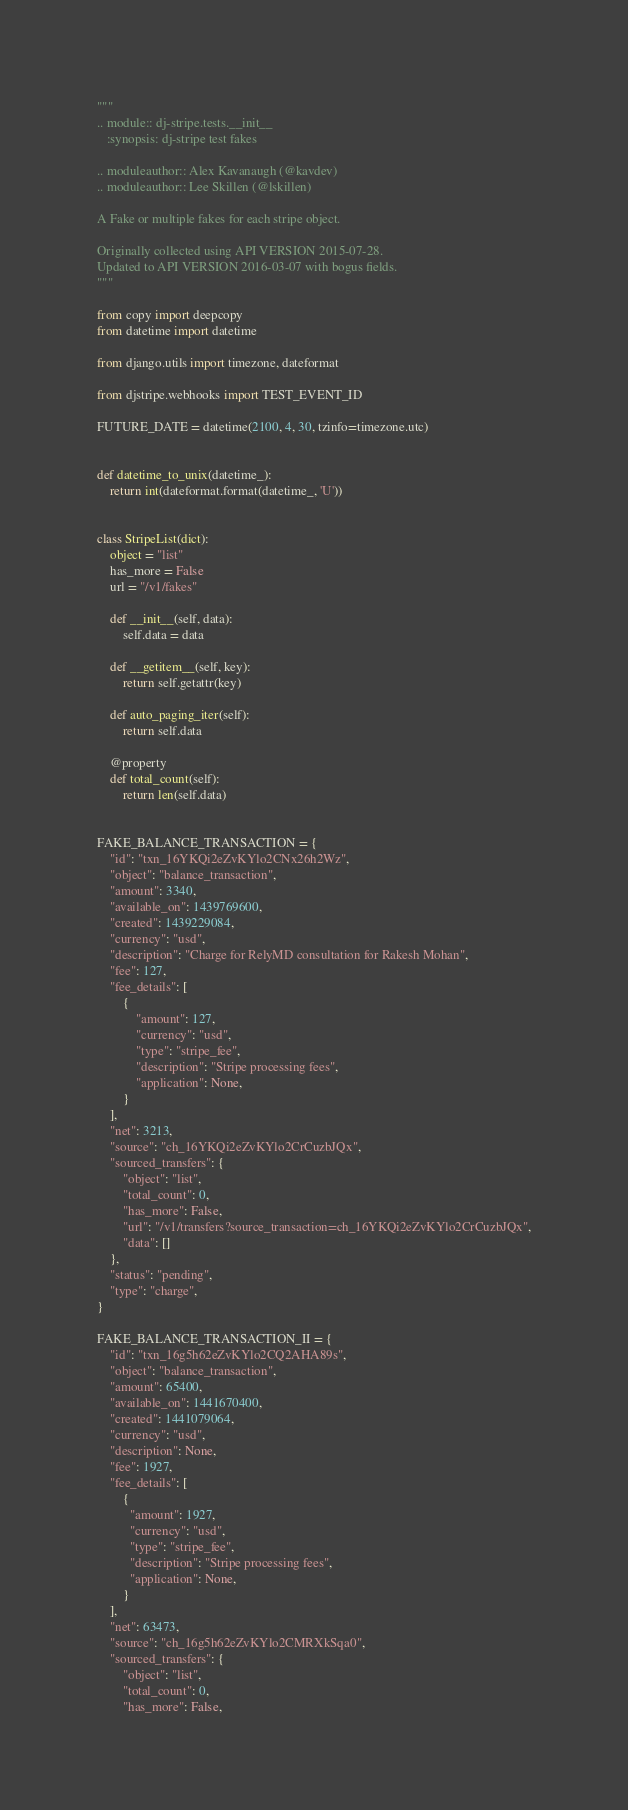<code> <loc_0><loc_0><loc_500><loc_500><_Python_>"""
.. module:: dj-stripe.tests.__init__
   :synopsis: dj-stripe test fakes

.. moduleauthor:: Alex Kavanaugh (@kavdev)
.. moduleauthor:: Lee Skillen (@lskillen)

A Fake or multiple fakes for each stripe object.

Originally collected using API VERSION 2015-07-28.
Updated to API VERSION 2016-03-07 with bogus fields.
"""

from copy import deepcopy
from datetime import datetime

from django.utils import timezone, dateformat

from djstripe.webhooks import TEST_EVENT_ID

FUTURE_DATE = datetime(2100, 4, 30, tzinfo=timezone.utc)


def datetime_to_unix(datetime_):
    return int(dateformat.format(datetime_, 'U'))


class StripeList(dict):
    object = "list"
    has_more = False
    url = "/v1/fakes"

    def __init__(self, data):
        self.data = data

    def __getitem__(self, key):
        return self.getattr(key)

    def auto_paging_iter(self):
        return self.data

    @property
    def total_count(self):
        return len(self.data)


FAKE_BALANCE_TRANSACTION = {
    "id": "txn_16YKQi2eZvKYlo2CNx26h2Wz",
    "object": "balance_transaction",
    "amount": 3340,
    "available_on": 1439769600,
    "created": 1439229084,
    "currency": "usd",
    "description": "Charge for RelyMD consultation for Rakesh Mohan",
    "fee": 127,
    "fee_details": [
        {
            "amount": 127,
            "currency": "usd",
            "type": "stripe_fee",
            "description": "Stripe processing fees",
            "application": None,
        }
    ],
    "net": 3213,
    "source": "ch_16YKQi2eZvKYlo2CrCuzbJQx",
    "sourced_transfers": {
        "object": "list",
        "total_count": 0,
        "has_more": False,
        "url": "/v1/transfers?source_transaction=ch_16YKQi2eZvKYlo2CrCuzbJQx",
        "data": []
    },
    "status": "pending",
    "type": "charge",
}

FAKE_BALANCE_TRANSACTION_II = {
    "id": "txn_16g5h62eZvKYlo2CQ2AHA89s",
    "object": "balance_transaction",
    "amount": 65400,
    "available_on": 1441670400,
    "created": 1441079064,
    "currency": "usd",
    "description": None,
    "fee": 1927,
    "fee_details": [
        {
          "amount": 1927,
          "currency": "usd",
          "type": "stripe_fee",
          "description": "Stripe processing fees",
          "application": None,
        }
    ],
    "net": 63473,
    "source": "ch_16g5h62eZvKYlo2CMRXkSqa0",
    "sourced_transfers": {
        "object": "list",
        "total_count": 0,
        "has_more": False,</code> 